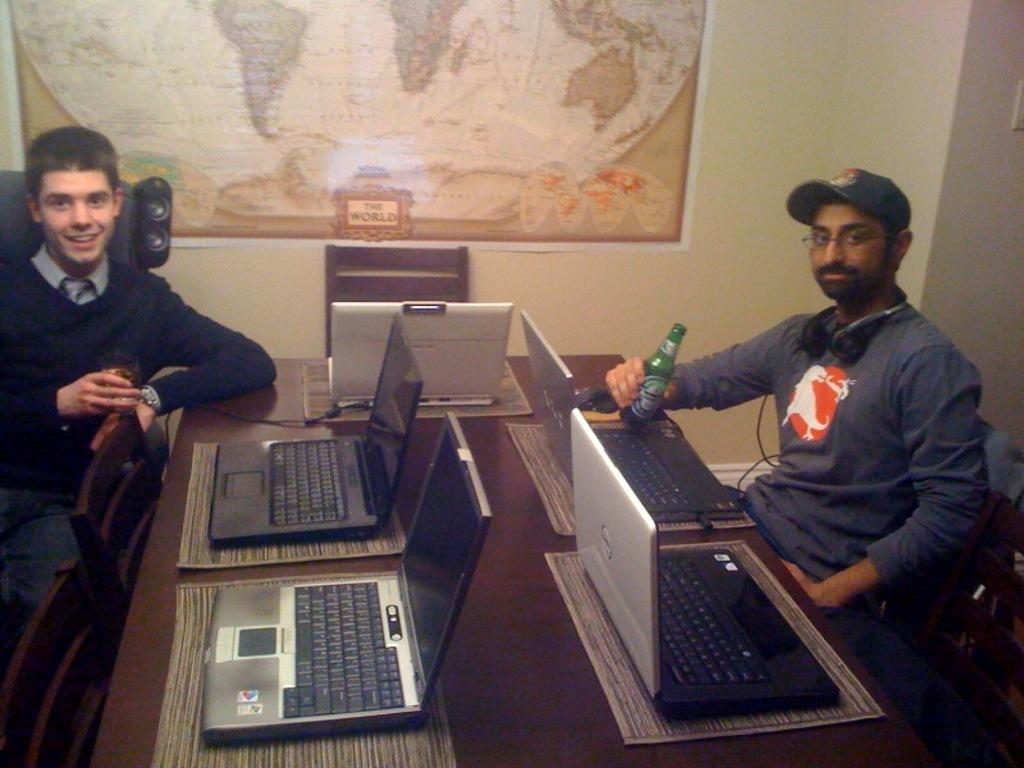How many people are in the image? There are two people in the image. What are the people doing in the image? The people are sitting in front of a table. What objects can be seen on the table? There are laptops on the table. What can be seen in the background of the image? There is a map and a chair in the background of the image. What type of doll is sitting on the chair in the background of the image? There is no doll present in the image; only a chair and a map can be seen in the background. 